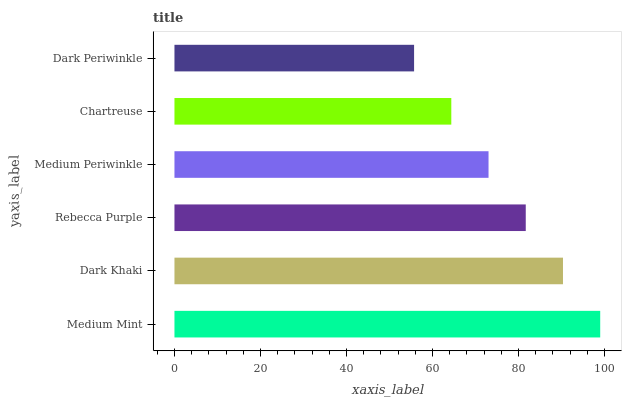Is Dark Periwinkle the minimum?
Answer yes or no. Yes. Is Medium Mint the maximum?
Answer yes or no. Yes. Is Dark Khaki the minimum?
Answer yes or no. No. Is Dark Khaki the maximum?
Answer yes or no. No. Is Medium Mint greater than Dark Khaki?
Answer yes or no. Yes. Is Dark Khaki less than Medium Mint?
Answer yes or no. Yes. Is Dark Khaki greater than Medium Mint?
Answer yes or no. No. Is Medium Mint less than Dark Khaki?
Answer yes or no. No. Is Rebecca Purple the high median?
Answer yes or no. Yes. Is Medium Periwinkle the low median?
Answer yes or no. Yes. Is Medium Mint the high median?
Answer yes or no. No. Is Rebecca Purple the low median?
Answer yes or no. No. 